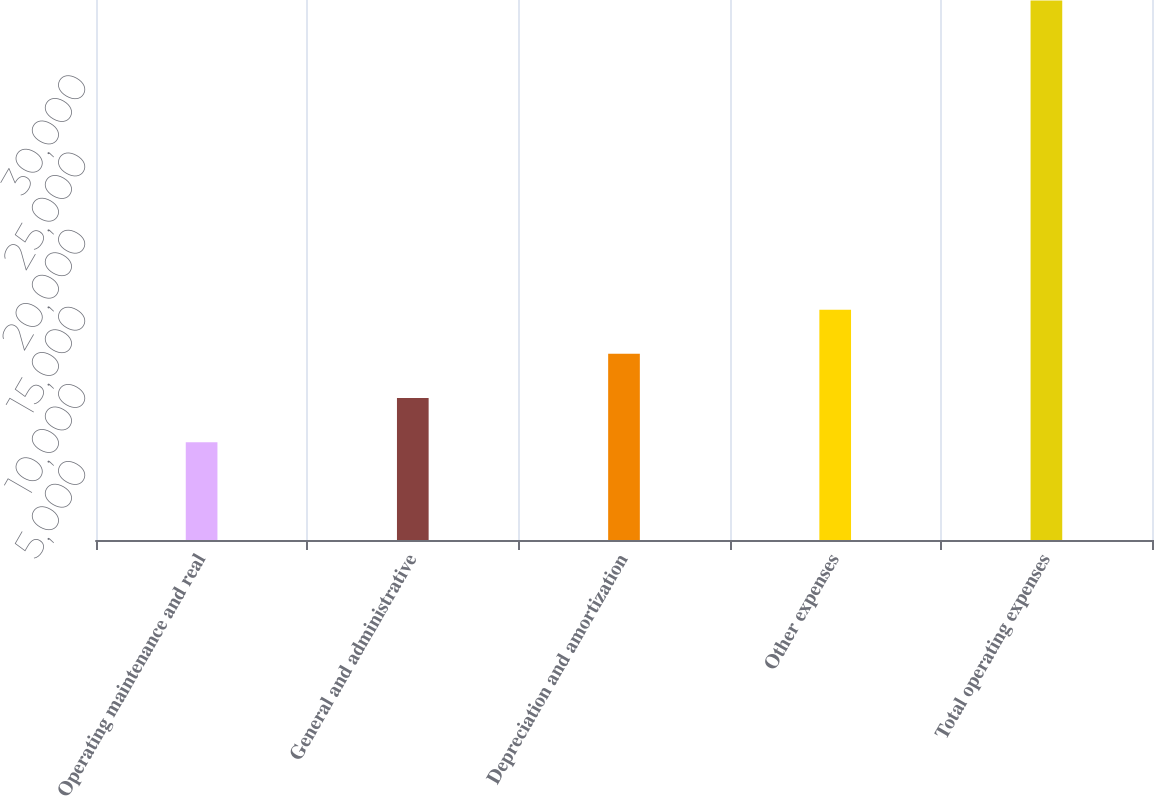Convert chart to OTSL. <chart><loc_0><loc_0><loc_500><loc_500><bar_chart><fcel>Operating maintenance and real<fcel>General and administrative<fcel>Depreciation and amortization<fcel>Other expenses<fcel>Total operating expenses<nl><fcel>6343<fcel>9204.8<fcel>12066.6<fcel>14928.4<fcel>34961<nl></chart> 